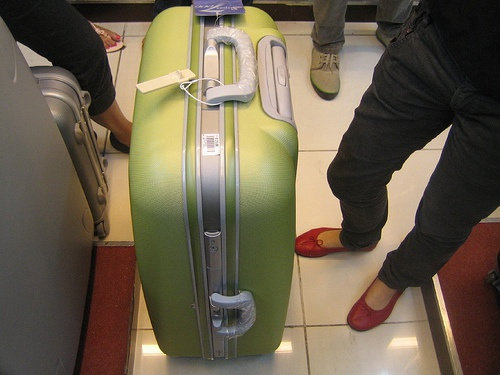Describe the objects in this image and their specific colors. I can see suitcase in black, darkgreen, olive, gray, and tan tones, people in black, maroon, and brown tones, suitcase in black and gray tones, people in black, maroon, and gray tones, and suitcase in black and gray tones in this image. 